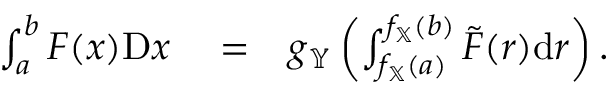<formula> <loc_0><loc_0><loc_500><loc_500>\begin{array} { r l r } { \int _ { a } ^ { b } F ( x ) D x } & = } & { g _ { \mathbb { Y } } \left ( \int _ { f _ { \mathbb { X } } ( a ) } ^ { f _ { \mathbb { X } } ( b ) } \tilde { F } ( r ) d r \right ) . } \end{array}</formula> 